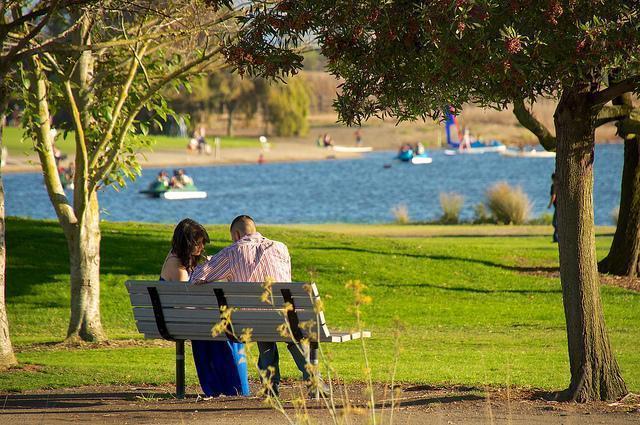What is rented for family enjoyment?
From the following four choices, select the correct answer to address the question.
Options: Scuba gear, boats, benches, kites. Boats. 